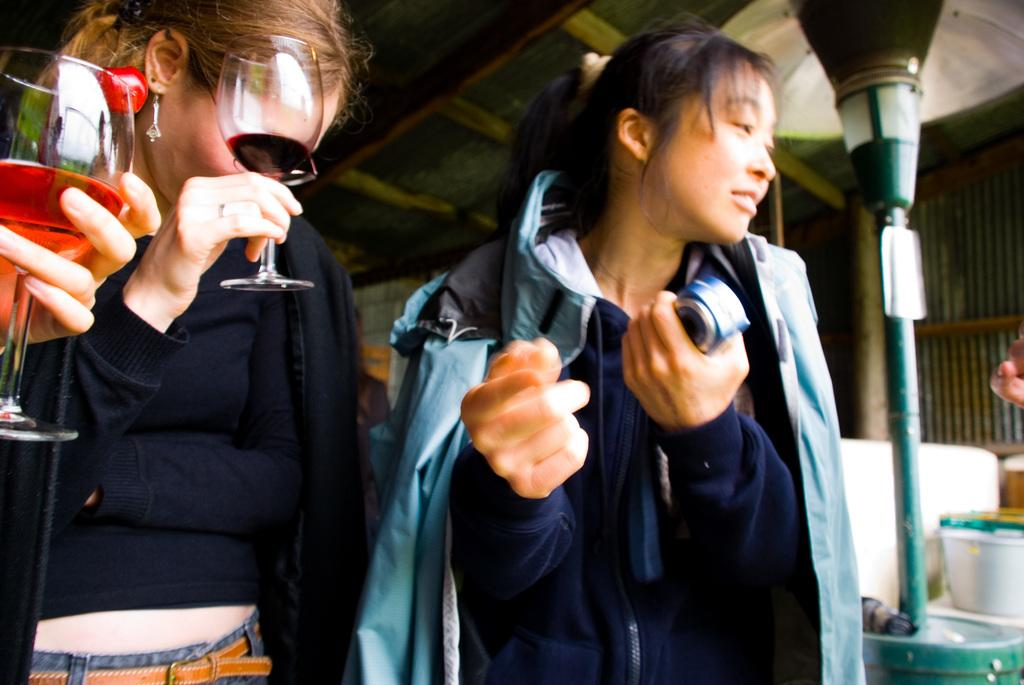How many women are in the image? There are two women in the image. What is one of the women holding in her hand? One of the women is holding a glass with her hand. What can be seen in the image besides the women? There is a pole, a box, and a roof in the image. What type of jellyfish can be seen swimming near the roof in the image? There are no jellyfish present in the image; it features two women, a pole, a box, and a roof. 